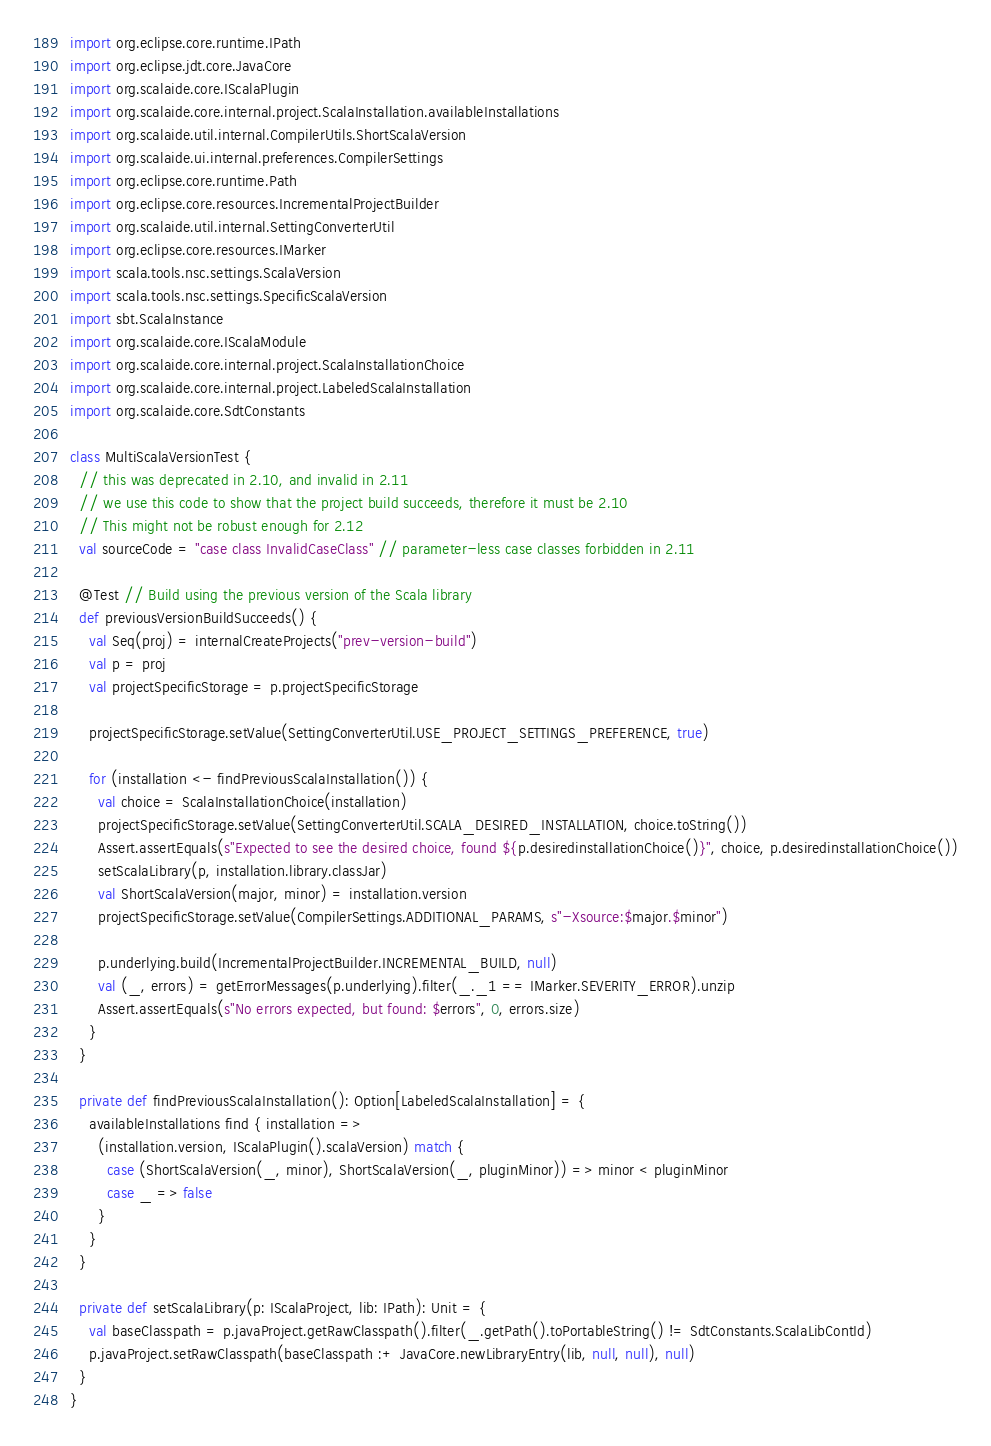<code> <loc_0><loc_0><loc_500><loc_500><_Scala_>import org.eclipse.core.runtime.IPath
import org.eclipse.jdt.core.JavaCore
import org.scalaide.core.IScalaPlugin
import org.scalaide.core.internal.project.ScalaInstallation.availableInstallations
import org.scalaide.util.internal.CompilerUtils.ShortScalaVersion
import org.scalaide.ui.internal.preferences.CompilerSettings
import org.eclipse.core.runtime.Path
import org.eclipse.core.resources.IncrementalProjectBuilder
import org.scalaide.util.internal.SettingConverterUtil
import org.eclipse.core.resources.IMarker
import scala.tools.nsc.settings.ScalaVersion
import scala.tools.nsc.settings.SpecificScalaVersion
import sbt.ScalaInstance
import org.scalaide.core.IScalaModule
import org.scalaide.core.internal.project.ScalaInstallationChoice
import org.scalaide.core.internal.project.LabeledScalaInstallation
import org.scalaide.core.SdtConstants

class MultiScalaVersionTest {
  // this was deprecated in 2.10, and invalid in 2.11
  // we use this code to show that the project build succeeds, therefore it must be 2.10
  // This might not be robust enough for 2.12
  val sourceCode = "case class InvalidCaseClass" // parameter-less case classes forbidden in 2.11

  @Test // Build using the previous version of the Scala library
  def previousVersionBuildSucceeds() {
    val Seq(proj) = internalCreateProjects("prev-version-build")
    val p = proj
    val projectSpecificStorage = p.projectSpecificStorage

    projectSpecificStorage.setValue(SettingConverterUtil.USE_PROJECT_SETTINGS_PREFERENCE, true)

    for (installation <- findPreviousScalaInstallation()) {
      val choice = ScalaInstallationChoice(installation)
      projectSpecificStorage.setValue(SettingConverterUtil.SCALA_DESIRED_INSTALLATION, choice.toString())
      Assert.assertEquals(s"Expected to see the desired choice, found ${p.desiredinstallationChoice()}", choice, p.desiredinstallationChoice())
      setScalaLibrary(p, installation.library.classJar)
      val ShortScalaVersion(major, minor) = installation.version
      projectSpecificStorage.setValue(CompilerSettings.ADDITIONAL_PARAMS, s"-Xsource:$major.$minor")

      p.underlying.build(IncrementalProjectBuilder.INCREMENTAL_BUILD, null)
      val (_, errors) = getErrorMessages(p.underlying).filter(_._1 == IMarker.SEVERITY_ERROR).unzip
      Assert.assertEquals(s"No errors expected, but found: $errors", 0, errors.size)
    }
  }

  private def findPreviousScalaInstallation(): Option[LabeledScalaInstallation] = {
    availableInstallations find { installation =>
      (installation.version, IScalaPlugin().scalaVersion) match {
        case (ShortScalaVersion(_, minor), ShortScalaVersion(_, pluginMinor)) => minor < pluginMinor
        case _ => false
      }
    }
  }

  private def setScalaLibrary(p: IScalaProject, lib: IPath): Unit = {
    val baseClasspath = p.javaProject.getRawClasspath().filter(_.getPath().toPortableString() != SdtConstants.ScalaLibContId)
    p.javaProject.setRawClasspath(baseClasspath :+ JavaCore.newLibraryEntry(lib, null, null), null)
  }
}</code> 